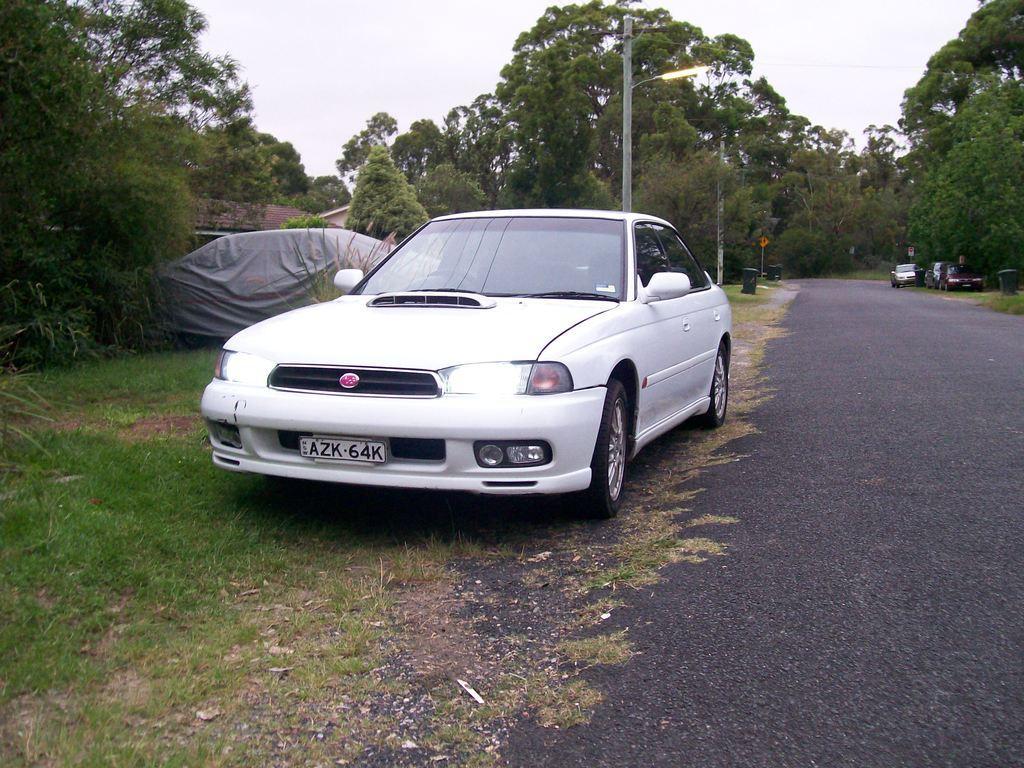Please provide a concise description of this image. In the picture I can see a white color car parked on the side of the road. On the left side of the image we can see another car covered with cover and on the right side of the image we can see a few more cars parked on the side of the road, we can see trees, light poles, trash can, horses, grass and the sky in the background. 